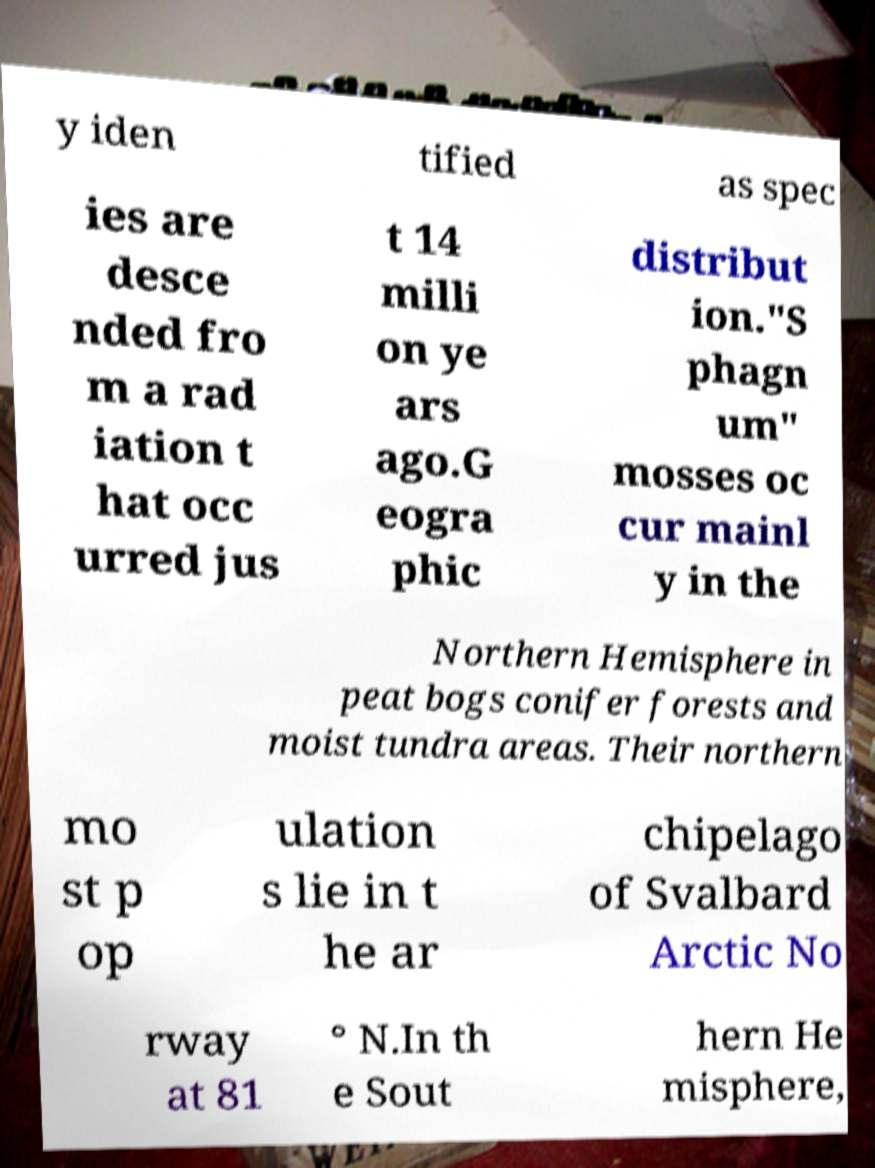Could you assist in decoding the text presented in this image and type it out clearly? y iden tified as spec ies are desce nded fro m a rad iation t hat occ urred jus t 14 milli on ye ars ago.G eogra phic distribut ion."S phagn um" mosses oc cur mainl y in the Northern Hemisphere in peat bogs conifer forests and moist tundra areas. Their northern mo st p op ulation s lie in t he ar chipelago of Svalbard Arctic No rway at 81 ° N.In th e Sout hern He misphere, 